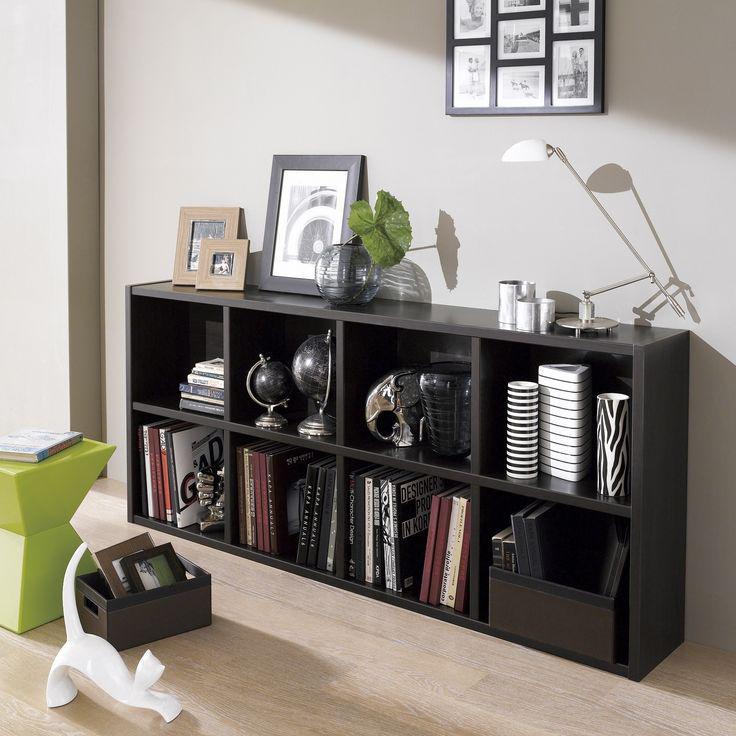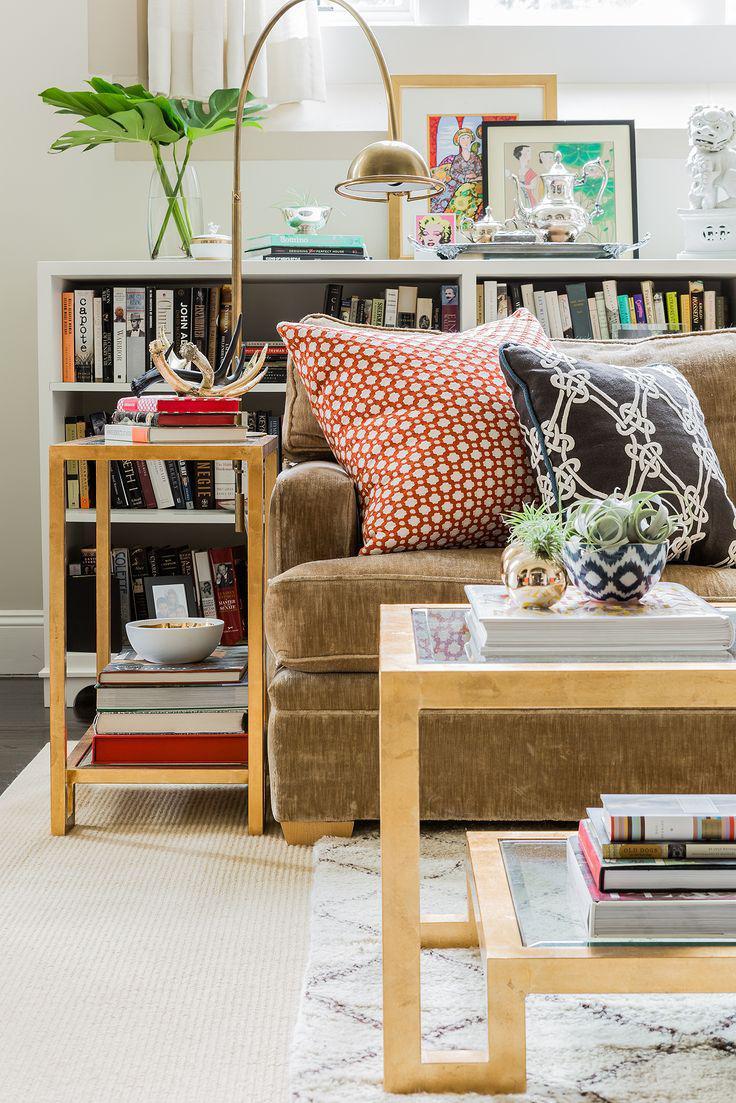The first image is the image on the left, the second image is the image on the right. Assess this claim about the two images: "A black bookshelf sits against the wall in one of the images.". Correct or not? Answer yes or no. Yes. The first image is the image on the left, the second image is the image on the right. Evaluate the accuracy of this statement regarding the images: "An image shows a sofa with neutral ecru cushions and bookshelves built into the sides.". Is it true? Answer yes or no. No. 